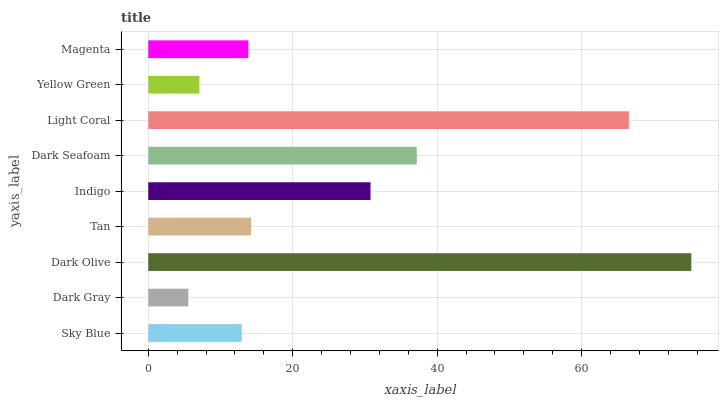Is Dark Gray the minimum?
Answer yes or no. Yes. Is Dark Olive the maximum?
Answer yes or no. Yes. Is Dark Olive the minimum?
Answer yes or no. No. Is Dark Gray the maximum?
Answer yes or no. No. Is Dark Olive greater than Dark Gray?
Answer yes or no. Yes. Is Dark Gray less than Dark Olive?
Answer yes or no. Yes. Is Dark Gray greater than Dark Olive?
Answer yes or no. No. Is Dark Olive less than Dark Gray?
Answer yes or no. No. Is Tan the high median?
Answer yes or no. Yes. Is Tan the low median?
Answer yes or no. Yes. Is Magenta the high median?
Answer yes or no. No. Is Dark Seafoam the low median?
Answer yes or no. No. 